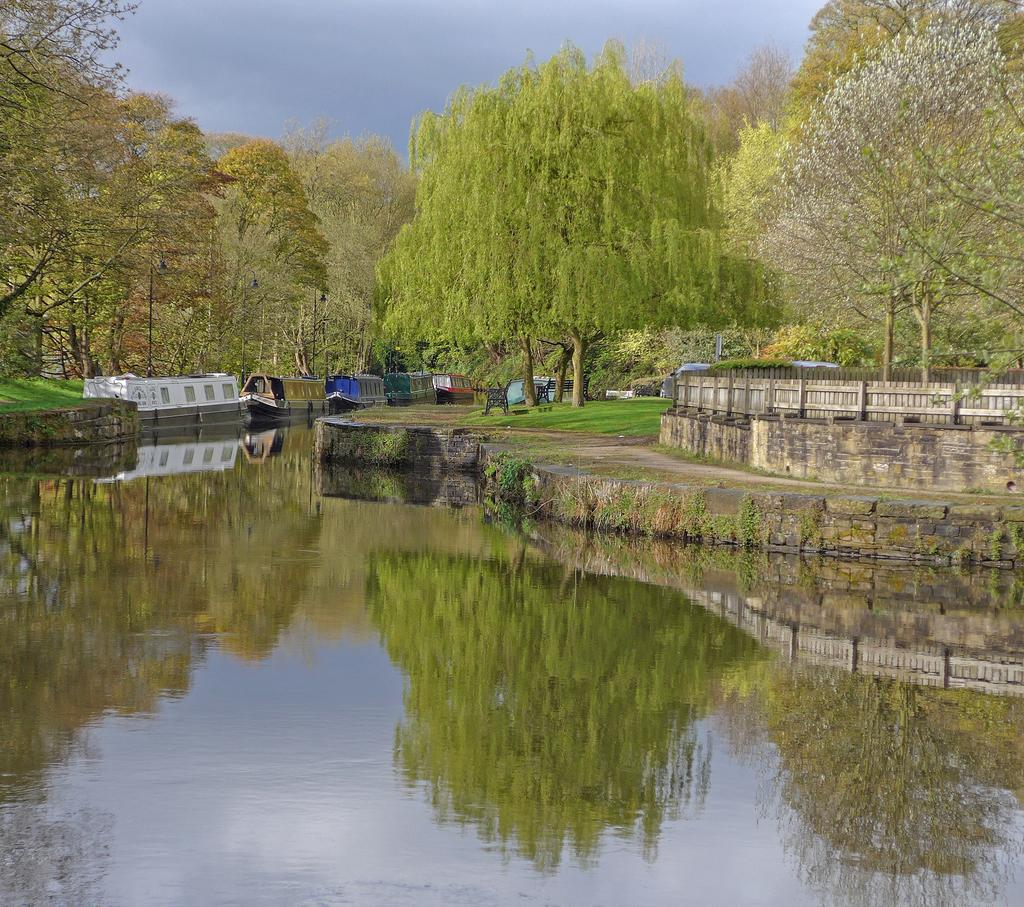What is on the water in the image? There are boats on the water in the image. What can be seen in the background of the image? There is grass, trees, and a wooden fence visible in the background of the image. How many books are stacked on the wooden fence in the image? There are no books present in the image; the wooden fence is part of the background scenery. 